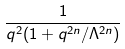<formula> <loc_0><loc_0><loc_500><loc_500>\frac { 1 } { q ^ { 2 } ( 1 + q ^ { 2 n } / \Lambda ^ { 2 n } ) }</formula> 